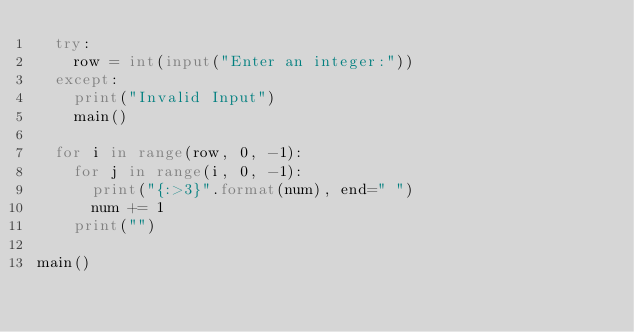<code> <loc_0><loc_0><loc_500><loc_500><_Python_>	try:
		row = int(input("Enter an integer:"))
	except:
		print("Invalid Input")
		main()

	for i in range(row, 0, -1):
		for j in range(i, 0, -1):
			print("{:>3}".format(num), end=" ")
			num += 1
		print("")

main()
</code> 